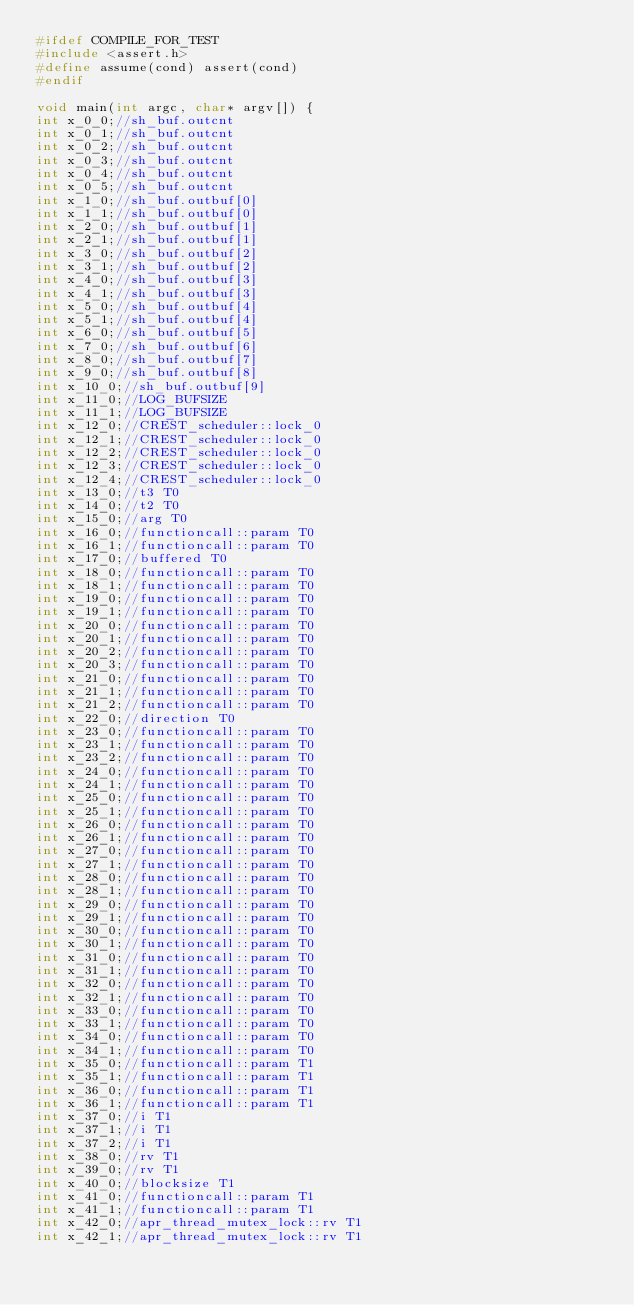<code> <loc_0><loc_0><loc_500><loc_500><_C_>#ifdef COMPILE_FOR_TEST
#include <assert.h>
#define assume(cond) assert(cond)
#endif

void main(int argc, char* argv[]) {
int x_0_0;//sh_buf.outcnt 
int x_0_1;//sh_buf.outcnt 
int x_0_2;//sh_buf.outcnt 
int x_0_3;//sh_buf.outcnt 
int x_0_4;//sh_buf.outcnt 
int x_0_5;//sh_buf.outcnt 
int x_1_0;//sh_buf.outbuf[0] 
int x_1_1;//sh_buf.outbuf[0] 
int x_2_0;//sh_buf.outbuf[1] 
int x_2_1;//sh_buf.outbuf[1] 
int x_3_0;//sh_buf.outbuf[2] 
int x_3_1;//sh_buf.outbuf[2] 
int x_4_0;//sh_buf.outbuf[3] 
int x_4_1;//sh_buf.outbuf[3] 
int x_5_0;//sh_buf.outbuf[4] 
int x_5_1;//sh_buf.outbuf[4] 
int x_6_0;//sh_buf.outbuf[5] 
int x_7_0;//sh_buf.outbuf[6] 
int x_8_0;//sh_buf.outbuf[7] 
int x_9_0;//sh_buf.outbuf[8] 
int x_10_0;//sh_buf.outbuf[9] 
int x_11_0;//LOG_BUFSIZE 
int x_11_1;//LOG_BUFSIZE 
int x_12_0;//CREST_scheduler::lock_0 
int x_12_1;//CREST_scheduler::lock_0 
int x_12_2;//CREST_scheduler::lock_0 
int x_12_3;//CREST_scheduler::lock_0 
int x_12_4;//CREST_scheduler::lock_0 
int x_13_0;//t3 T0
int x_14_0;//t2 T0
int x_15_0;//arg T0
int x_16_0;//functioncall::param T0
int x_16_1;//functioncall::param T0
int x_17_0;//buffered T0
int x_18_0;//functioncall::param T0
int x_18_1;//functioncall::param T0
int x_19_0;//functioncall::param T0
int x_19_1;//functioncall::param T0
int x_20_0;//functioncall::param T0
int x_20_1;//functioncall::param T0
int x_20_2;//functioncall::param T0
int x_20_3;//functioncall::param T0
int x_21_0;//functioncall::param T0
int x_21_1;//functioncall::param T0
int x_21_2;//functioncall::param T0
int x_22_0;//direction T0
int x_23_0;//functioncall::param T0
int x_23_1;//functioncall::param T0
int x_23_2;//functioncall::param T0
int x_24_0;//functioncall::param T0
int x_24_1;//functioncall::param T0
int x_25_0;//functioncall::param T0
int x_25_1;//functioncall::param T0
int x_26_0;//functioncall::param T0
int x_26_1;//functioncall::param T0
int x_27_0;//functioncall::param T0
int x_27_1;//functioncall::param T0
int x_28_0;//functioncall::param T0
int x_28_1;//functioncall::param T0
int x_29_0;//functioncall::param T0
int x_29_1;//functioncall::param T0
int x_30_0;//functioncall::param T0
int x_30_1;//functioncall::param T0
int x_31_0;//functioncall::param T0
int x_31_1;//functioncall::param T0
int x_32_0;//functioncall::param T0
int x_32_1;//functioncall::param T0
int x_33_0;//functioncall::param T0
int x_33_1;//functioncall::param T0
int x_34_0;//functioncall::param T0
int x_34_1;//functioncall::param T0
int x_35_0;//functioncall::param T1
int x_35_1;//functioncall::param T1
int x_36_0;//functioncall::param T1
int x_36_1;//functioncall::param T1
int x_37_0;//i T1
int x_37_1;//i T1
int x_37_2;//i T1
int x_38_0;//rv T1
int x_39_0;//rv T1
int x_40_0;//blocksize T1
int x_41_0;//functioncall::param T1
int x_41_1;//functioncall::param T1
int x_42_0;//apr_thread_mutex_lock::rv T1
int x_42_1;//apr_thread_mutex_lock::rv T1</code> 